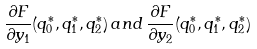<formula> <loc_0><loc_0><loc_500><loc_500>\frac { \partial F } { \partial y _ { 1 } } ( q _ { 0 } ^ { * } , q _ { 1 } ^ { * } , q _ { 2 } ^ { * } ) \, a n d \, \frac { \partial F } { \partial y _ { 2 } } ( q _ { 0 } ^ { * } , q _ { 1 } ^ { * } , q _ { 2 } ^ { * } )</formula> 